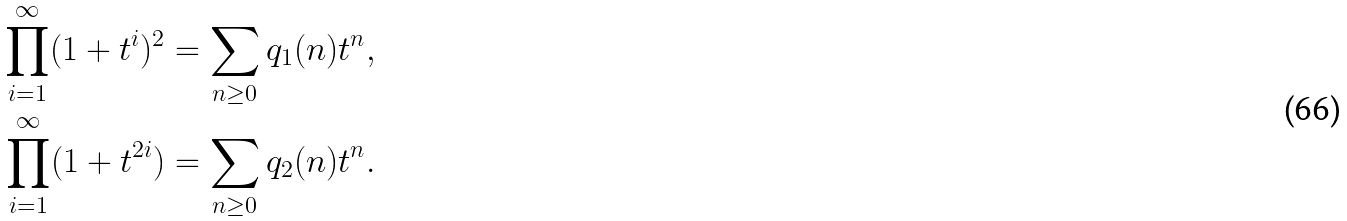<formula> <loc_0><loc_0><loc_500><loc_500>\prod _ { i = 1 } ^ { \infty } ( 1 + t ^ { i } ) ^ { 2 } & = \sum _ { n \geq 0 } q _ { 1 } ( n ) t ^ { n } , \\ \prod _ { i = 1 } ^ { \infty } ( 1 + t ^ { 2 i } ) & = \sum _ { n \geq 0 } q _ { 2 } ( n ) t ^ { n } .</formula> 